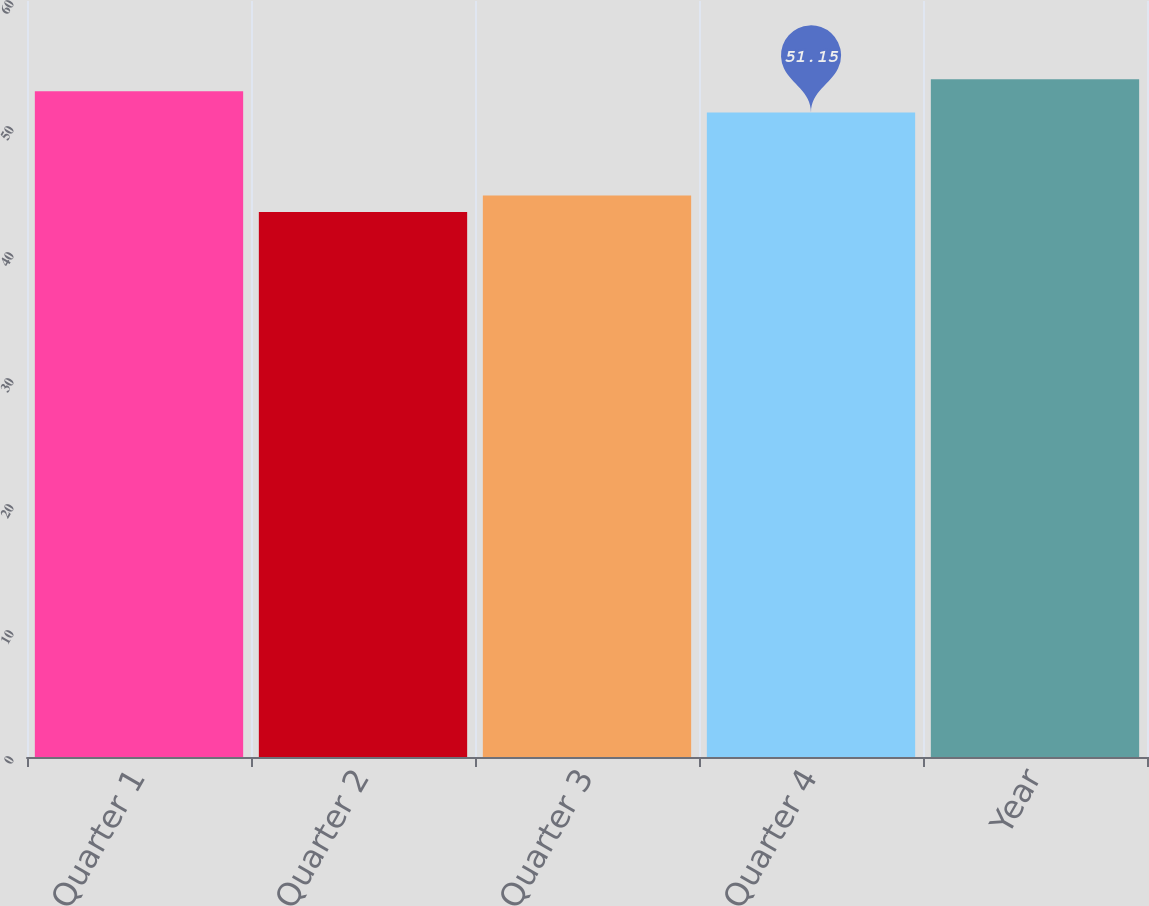Convert chart. <chart><loc_0><loc_0><loc_500><loc_500><bar_chart><fcel>Quarter 1<fcel>Quarter 2<fcel>Quarter 3<fcel>Quarter 4<fcel>Year<nl><fcel>52.83<fcel>43.26<fcel>44.56<fcel>51.15<fcel>53.79<nl></chart> 